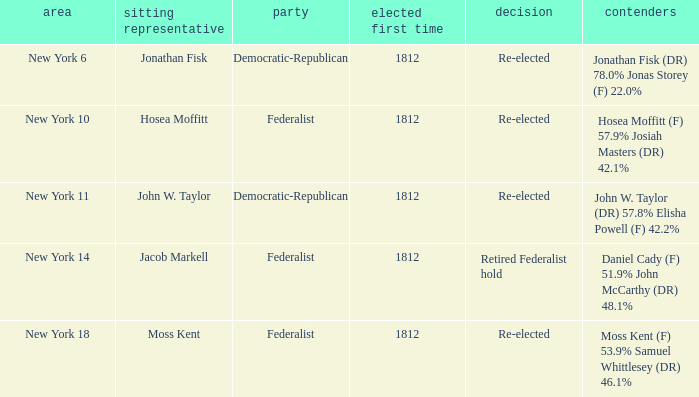Name the most first elected 1812.0. 